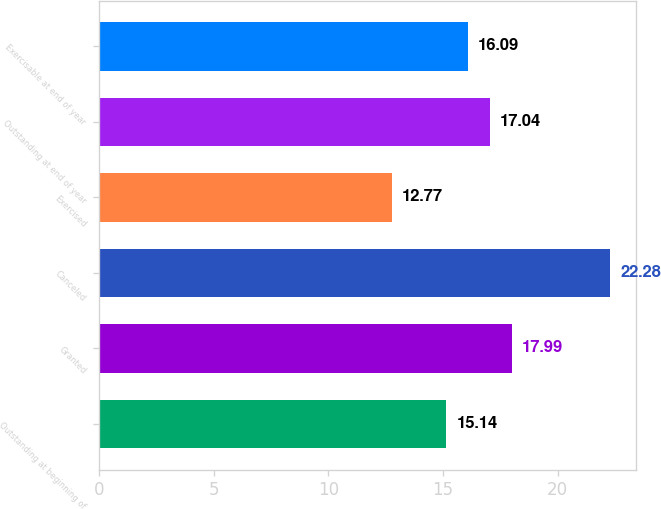Convert chart. <chart><loc_0><loc_0><loc_500><loc_500><bar_chart><fcel>Outstanding at beginning of<fcel>Granted<fcel>Canceled<fcel>Exercised<fcel>Outstanding at end of year<fcel>Exercisable at end of year<nl><fcel>15.14<fcel>17.99<fcel>22.28<fcel>12.77<fcel>17.04<fcel>16.09<nl></chart> 